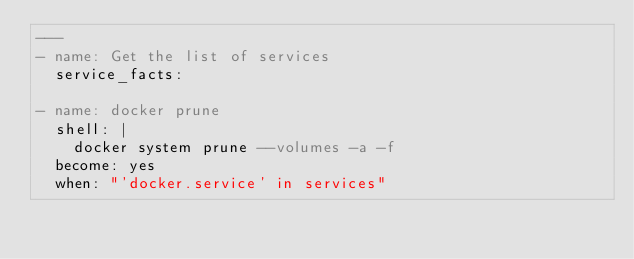Convert code to text. <code><loc_0><loc_0><loc_500><loc_500><_YAML_>---
- name: Get the list of services
  service_facts:

- name: docker prune
  shell: |
    docker system prune --volumes -a -f
  become: yes
  when: "'docker.service' in services"
</code> 